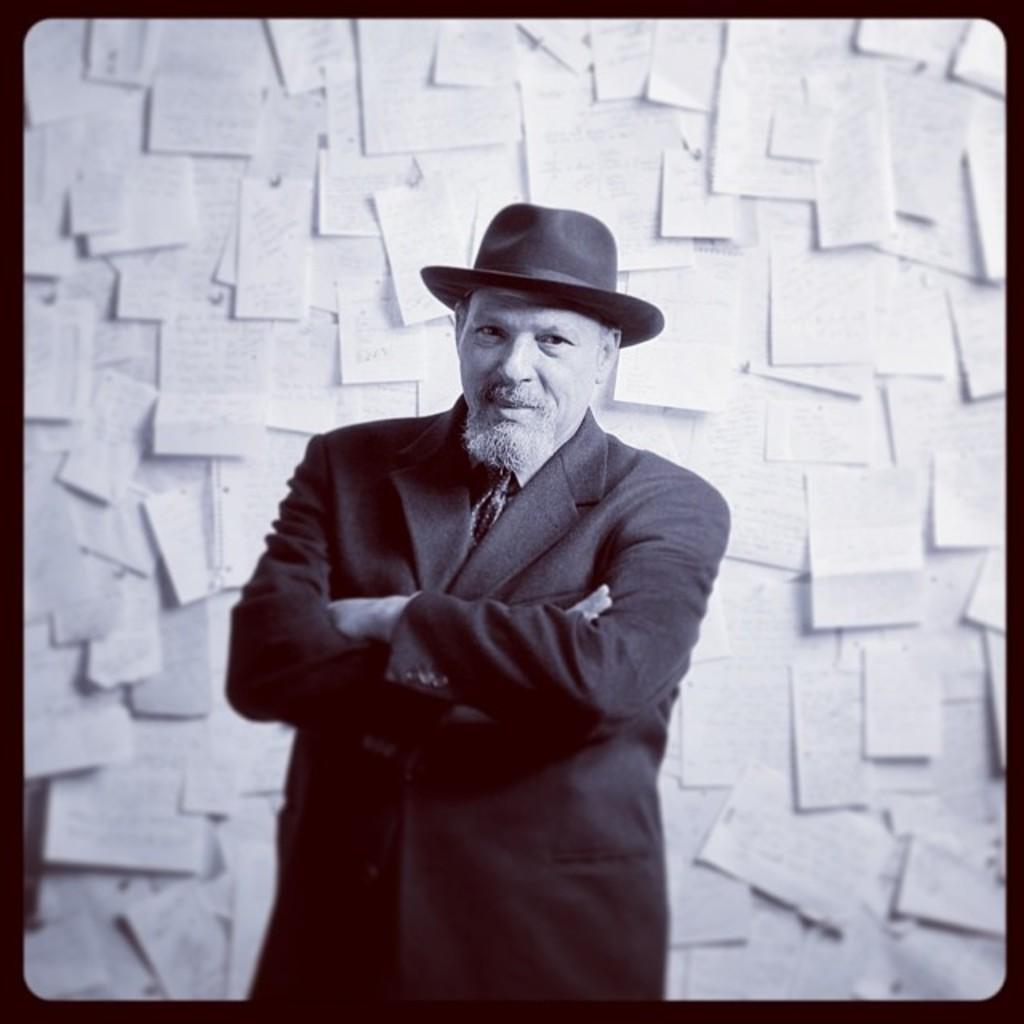How would you summarize this image in a sentence or two? This is an edited black and white picture where we can see a man in suit and hat is standing in the front and in the background, there are many papers seems to be pasted on the wall. 